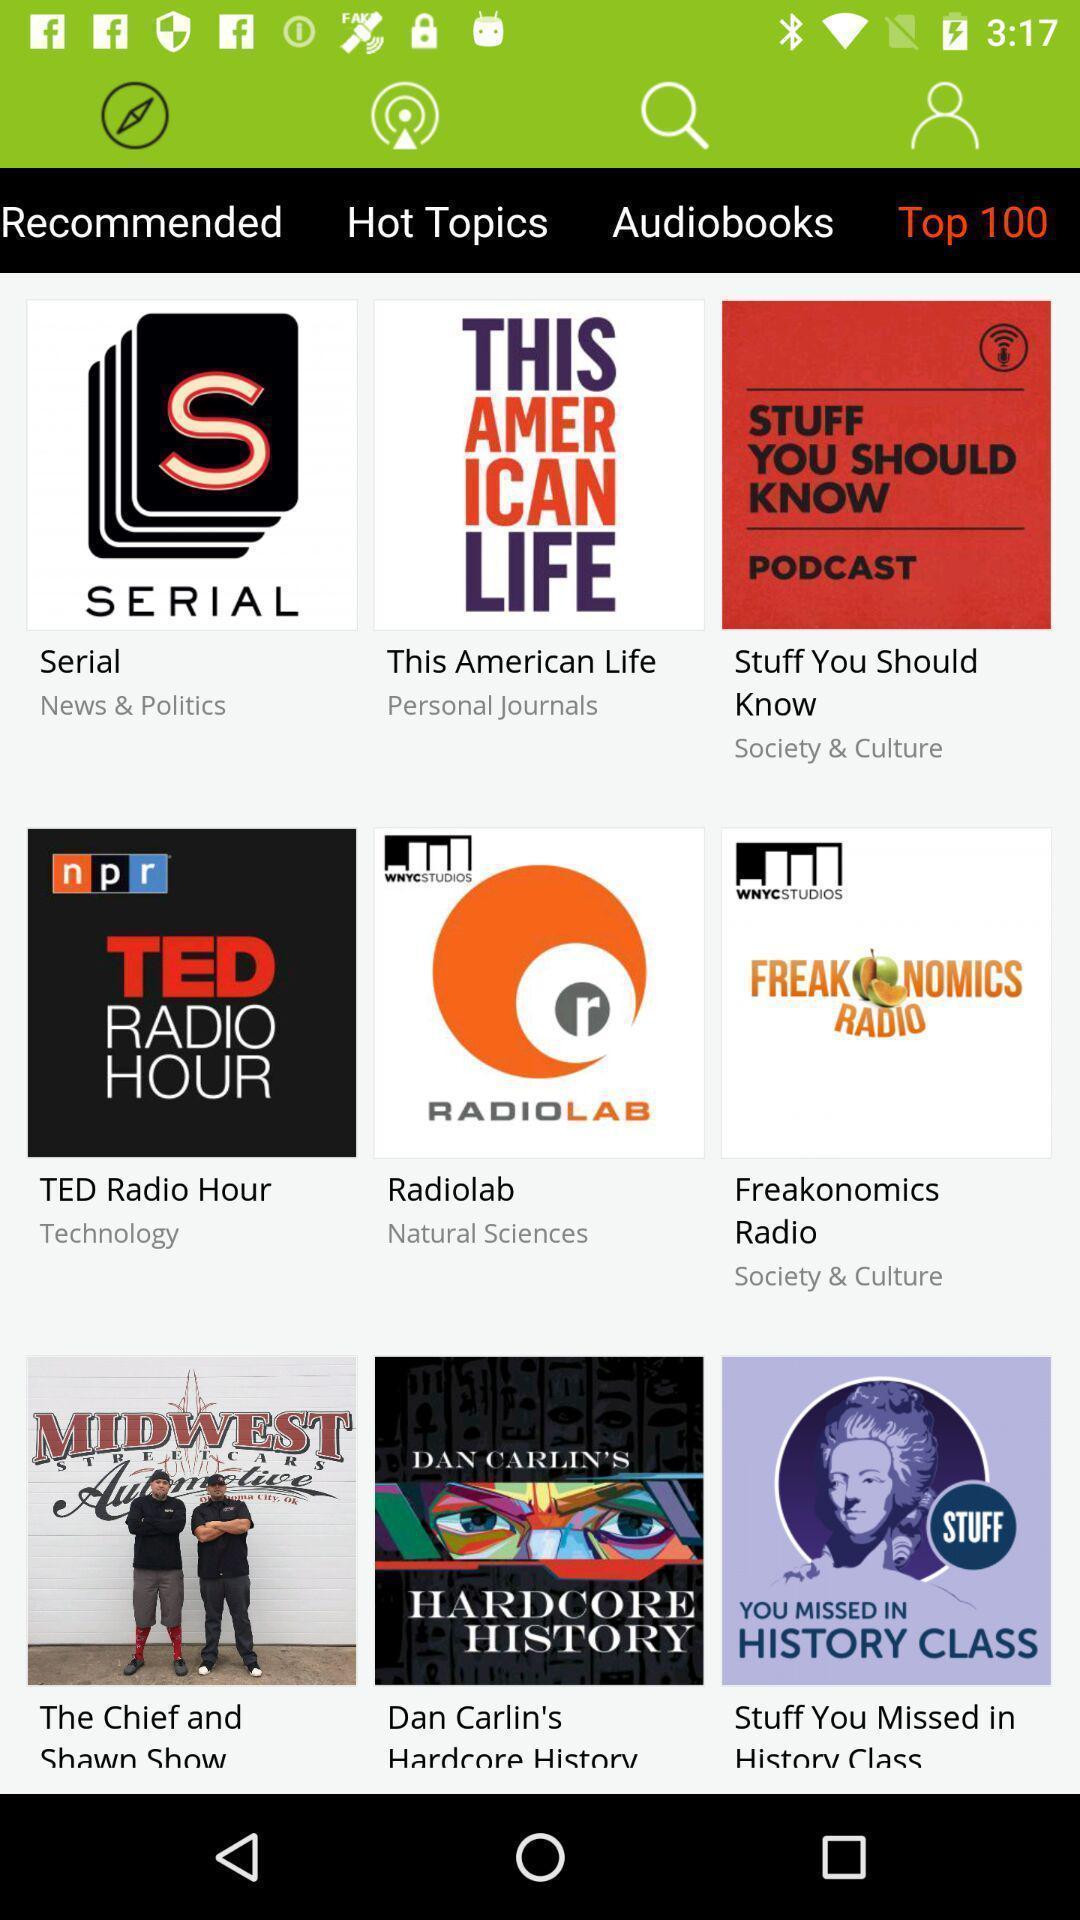What can you discern from this picture? Page showing different podcasts on an app. 